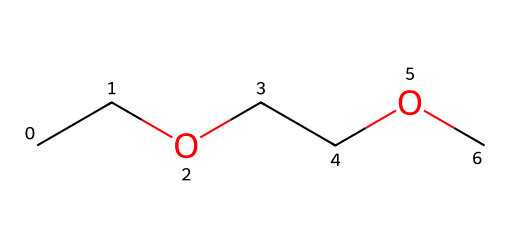What type of chemical is represented by this structure? The provided SMILES structure represents an ether because it contains an oxygen atom bonded to two alkyl groups. The presence of the ether functional group (R-O-R’) indicates it is an ether.
Answer: ether How many carbon atoms are in this compound? In the given SMILES, there are five carbon atoms (two from each ethyl group and one in the middle connected to the oxygen). Counting each "C" in the structure confirms this.
Answer: five What is the molecular formula of this ether? By counting the atoms in the SMILES, we find it consists of five carbon atoms, twelve hydrogen atoms, and one oxygen atom, which gives the molecular formula C5H12O.
Answer: C5H12O How many oxygen atoms are there in this molecule? In the provided SMILES representation, there is one oxygen atom between the two carbon chains, indicating that the molecule contains a single ether functional group.
Answer: one What type of bonds are present in this ether? The ether has single bonds only; carbon atoms are connected to each other and to the oxygen with single covalent bonds. Analyzing the SMILES structure shows no double or triple bonds present.
Answer: single bonds Is this ether polar or nonpolar? Given that this ether contains significant carbon content and one oxygen, it exhibits characteristics of both polar and nonpolar regions, but it is primarily considered nonpolar due to the larger hydrocarbon portion.
Answer: nonpolar 